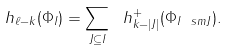Convert formula to latex. <formula><loc_0><loc_0><loc_500><loc_500>h _ { \ell - k } ( \Phi _ { I } ) = \sum _ { J \subseteq I } \ h ^ { + } _ { k - | J | } ( \Phi _ { I \ s m J } ) .</formula> 